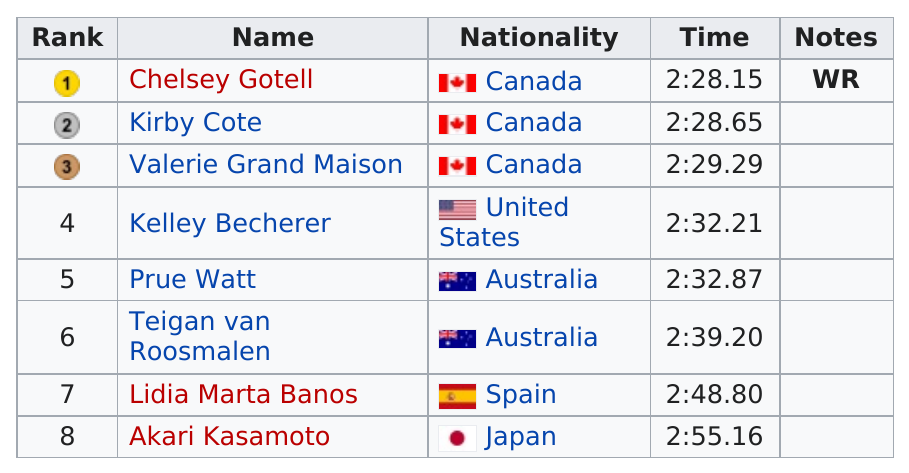List a handful of essential elements in this visual. There were three Canadian swimmers present. In the competition, there were two swimmers from Australia: one was Watt, and the other was Teigan van Roosmalen. Two racers from Australia competed in the race. The Australian competitors are Prue Watt and Teigan van Roosmalen. The top three runners came from Canada. 